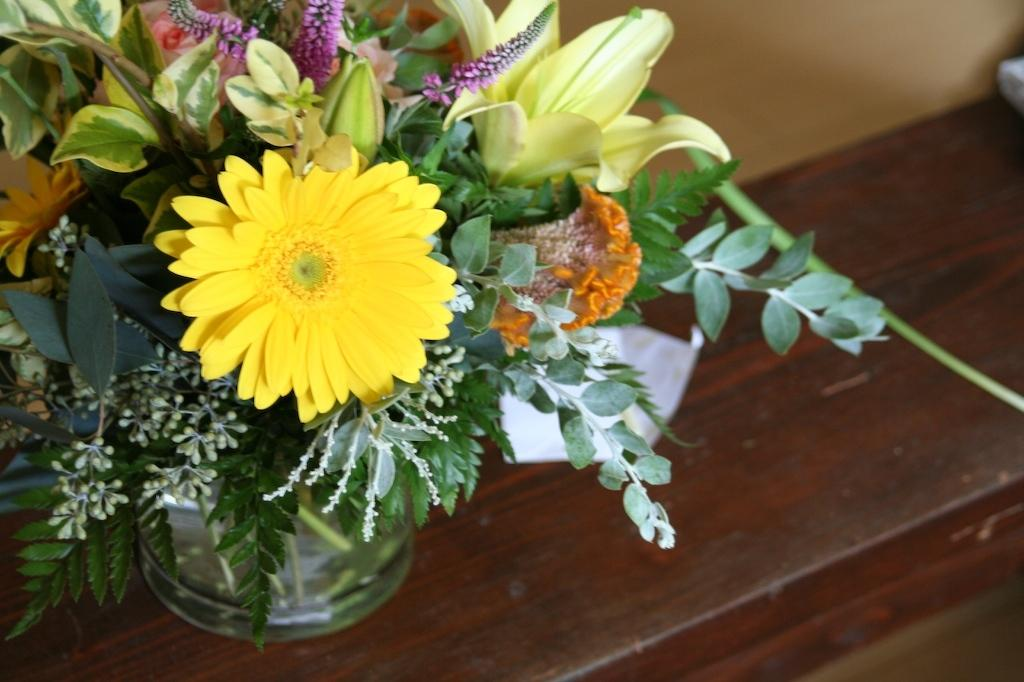What object is present in the image that typically holds flowers? There is a flower vase in the image. Where is the flower vase located in the image? The flower vase is placed on a table. What types of flowers are in the vase? There are different colored flowers in the vase. Are there any other parts of the plants visible in the vase? Yes, there are leaves in the vase. Is there a baseball bat leaning against the flower vase in the image? No, there is no baseball bat or any sports equipment present in the image. 